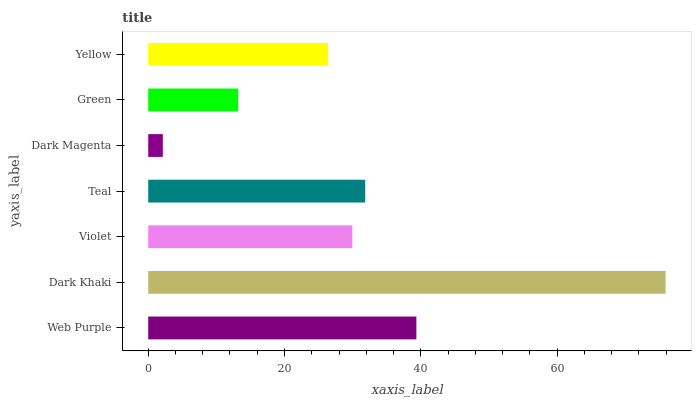Is Dark Magenta the minimum?
Answer yes or no. Yes. Is Dark Khaki the maximum?
Answer yes or no. Yes. Is Violet the minimum?
Answer yes or no. No. Is Violet the maximum?
Answer yes or no. No. Is Dark Khaki greater than Violet?
Answer yes or no. Yes. Is Violet less than Dark Khaki?
Answer yes or no. Yes. Is Violet greater than Dark Khaki?
Answer yes or no. No. Is Dark Khaki less than Violet?
Answer yes or no. No. Is Violet the high median?
Answer yes or no. Yes. Is Violet the low median?
Answer yes or no. Yes. Is Teal the high median?
Answer yes or no. No. Is Dark Magenta the low median?
Answer yes or no. No. 